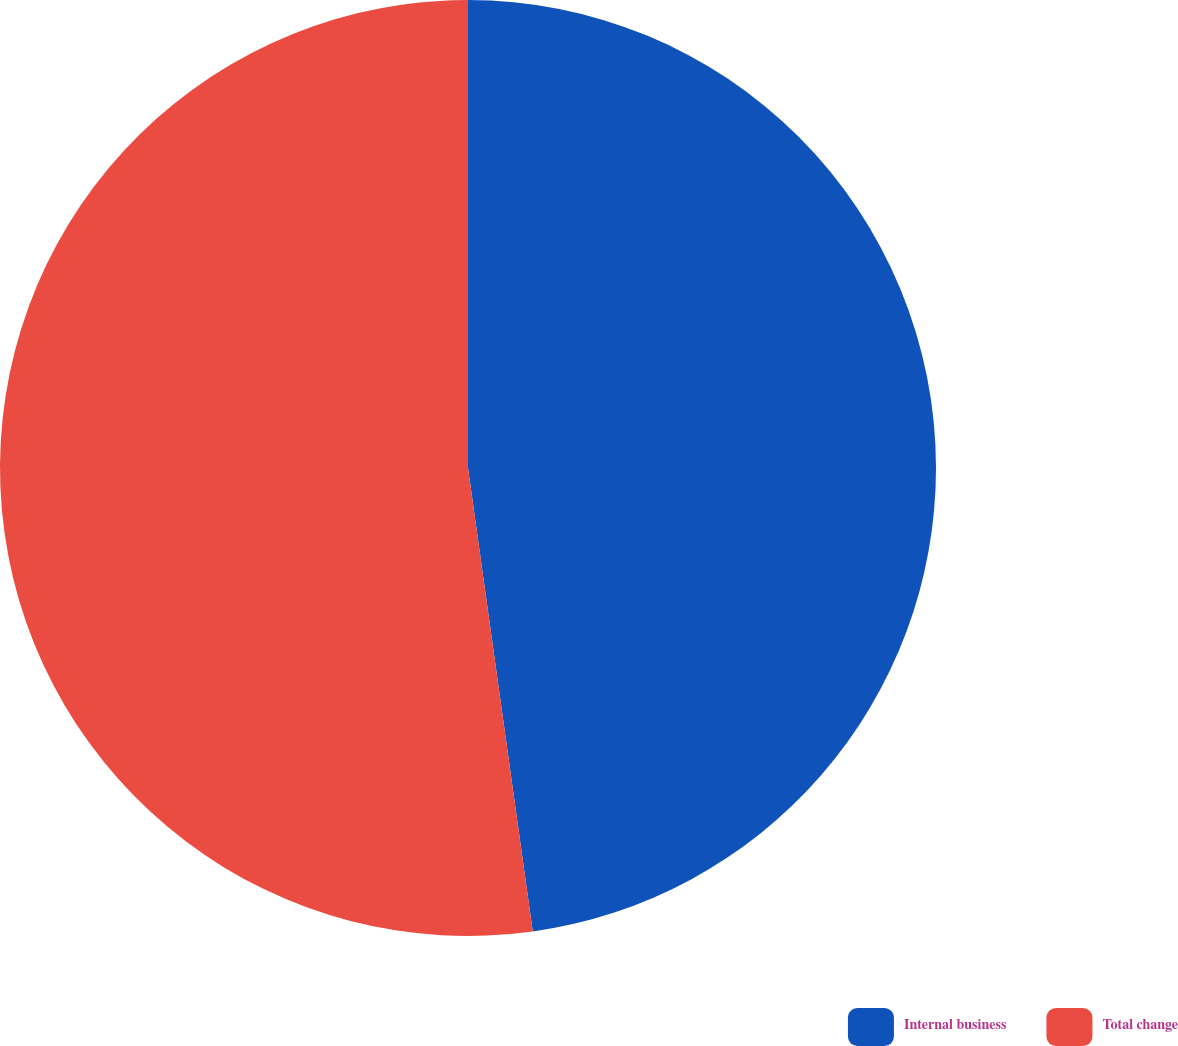Convert chart to OTSL. <chart><loc_0><loc_0><loc_500><loc_500><pie_chart><fcel>Internal business<fcel>Total change<nl><fcel>47.79%<fcel>52.21%<nl></chart> 